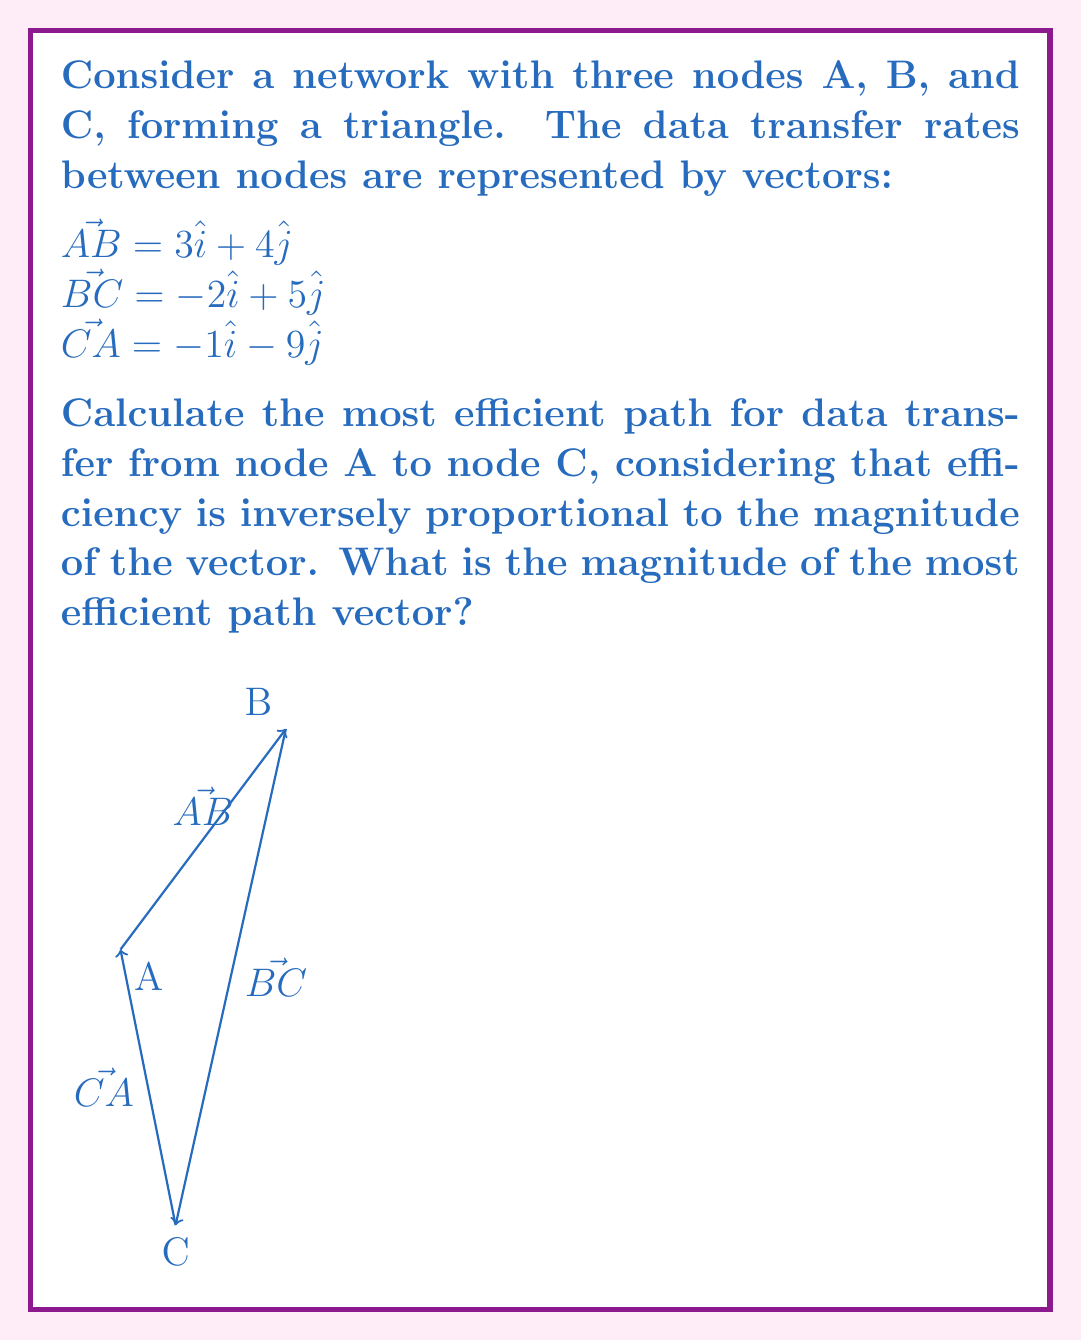Give your solution to this math problem. To solve this problem, we need to consider the two possible paths from A to C:
1. Direct path: $\vec{AC} = -\vec{CA}$
2. Indirect path: $\vec{AB} + \vec{BC}$

Let's calculate the magnitudes of these paths:

1. Direct path $\vec{AC}$:
   $\vec{AC} = -(-1\hat{i} - 9\hat{j}) = 1\hat{i} + 9\hat{j}$
   Magnitude: $|\vec{AC}| = \sqrt{1^2 + 9^2} = \sqrt{82}$

2. Indirect path $\vec{AB} + \vec{BC}$:
   $\vec{AB} + \vec{BC} = (3\hat{i} + 4\hat{j}) + (-2\hat{i} + 5\hat{j}) = 1\hat{i} + 9\hat{j}$
   Magnitude: $|\vec{AB} + \vec{BC}| = \sqrt{1^2 + 9^2} = \sqrt{82}$

Both paths have the same magnitude, $\sqrt{82}$. Since efficiency is inversely proportional to the magnitude, both paths are equally efficient.

To relate this to our IT colleague persona, we can think of this as optimizing data transfer in a network. The shorter path (smaller magnitude) represents less time or energy needed for data transfer, which aligns with the goal of maintaining efficiency in a demanding IT profession.
Answer: The magnitude of the most efficient path vector is $\sqrt{82}$. 